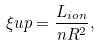<formula> <loc_0><loc_0><loc_500><loc_500>\xi u p = \frac { L _ { i o n } } { n R ^ { 2 } } ,</formula> 